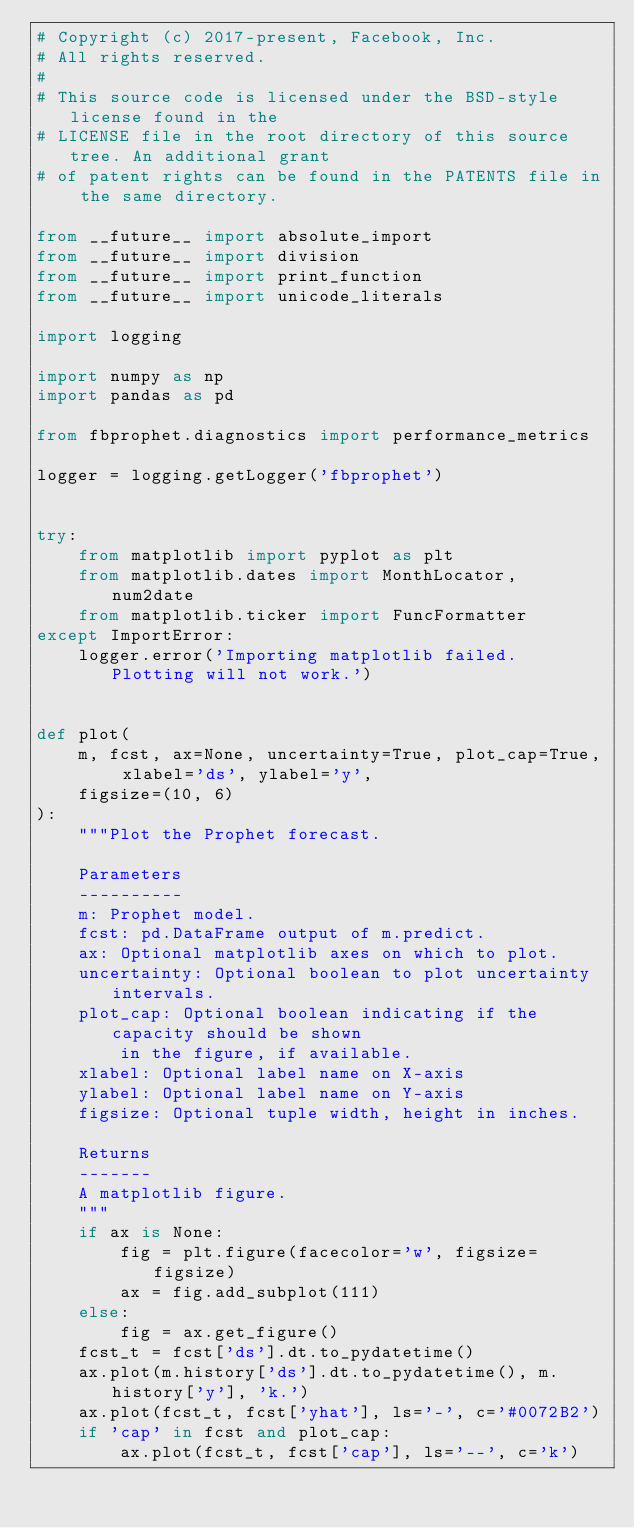Convert code to text. <code><loc_0><loc_0><loc_500><loc_500><_Python_># Copyright (c) 2017-present, Facebook, Inc.
# All rights reserved.
#
# This source code is licensed under the BSD-style license found in the
# LICENSE file in the root directory of this source tree. An additional grant
# of patent rights can be found in the PATENTS file in the same directory.

from __future__ import absolute_import
from __future__ import division
from __future__ import print_function
from __future__ import unicode_literals

import logging

import numpy as np
import pandas as pd

from fbprophet.diagnostics import performance_metrics

logger = logging.getLogger('fbprophet')


try:
    from matplotlib import pyplot as plt
    from matplotlib.dates import MonthLocator, num2date
    from matplotlib.ticker import FuncFormatter
except ImportError:
    logger.error('Importing matplotlib failed. Plotting will not work.')


def plot(
    m, fcst, ax=None, uncertainty=True, plot_cap=True, xlabel='ds', ylabel='y',
    figsize=(10, 6)
):
    """Plot the Prophet forecast.

    Parameters
    ----------
    m: Prophet model.
    fcst: pd.DataFrame output of m.predict.
    ax: Optional matplotlib axes on which to plot.
    uncertainty: Optional boolean to plot uncertainty intervals.
    plot_cap: Optional boolean indicating if the capacity should be shown
        in the figure, if available.
    xlabel: Optional label name on X-axis
    ylabel: Optional label name on Y-axis
    figsize: Optional tuple width, height in inches.

    Returns
    -------
    A matplotlib figure.
    """
    if ax is None:
        fig = plt.figure(facecolor='w', figsize=figsize)
        ax = fig.add_subplot(111)
    else:
        fig = ax.get_figure()
    fcst_t = fcst['ds'].dt.to_pydatetime()
    ax.plot(m.history['ds'].dt.to_pydatetime(), m.history['y'], 'k.')
    ax.plot(fcst_t, fcst['yhat'], ls='-', c='#0072B2')
    if 'cap' in fcst and plot_cap:
        ax.plot(fcst_t, fcst['cap'], ls='--', c='k')</code> 